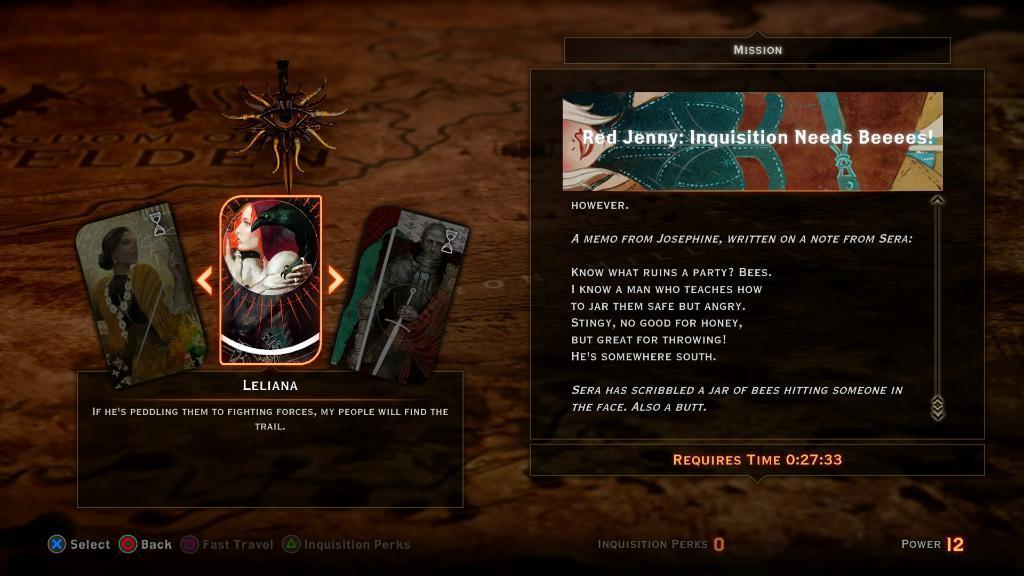Describe this image in one or two sentences. This is an animated image. In this picture, we see three cards are placed on the black box. On the right side, we see a board in black color with some text written on it. In the background, it is brown in color. This might be an edited image. 